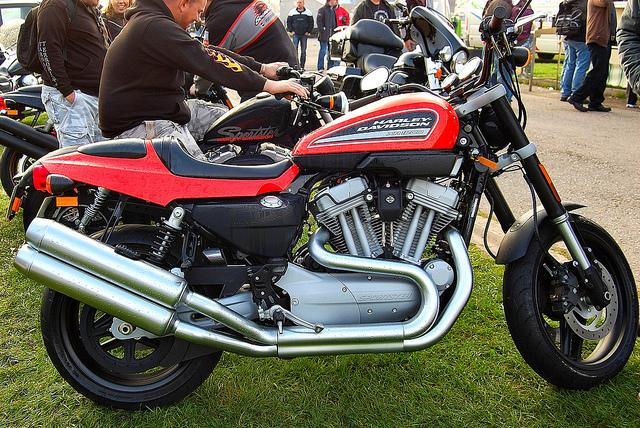What was the first name of Mr. Harley? william 